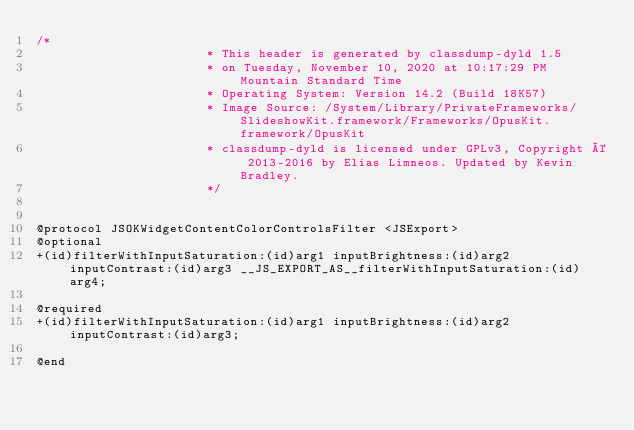<code> <loc_0><loc_0><loc_500><loc_500><_C_>/*
                       * This header is generated by classdump-dyld 1.5
                       * on Tuesday, November 10, 2020 at 10:17:29 PM Mountain Standard Time
                       * Operating System: Version 14.2 (Build 18K57)
                       * Image Source: /System/Library/PrivateFrameworks/SlideshowKit.framework/Frameworks/OpusKit.framework/OpusKit
                       * classdump-dyld is licensed under GPLv3, Copyright © 2013-2016 by Elias Limneos. Updated by Kevin Bradley.
                       */


@protocol JSOKWidgetContentColorControlsFilter <JSExport>
@optional
+(id)filterWithInputSaturation:(id)arg1 inputBrightness:(id)arg2 inputContrast:(id)arg3 __JS_EXPORT_AS__filterWithInputSaturation:(id)arg4;

@required
+(id)filterWithInputSaturation:(id)arg1 inputBrightness:(id)arg2 inputContrast:(id)arg3;

@end

</code> 